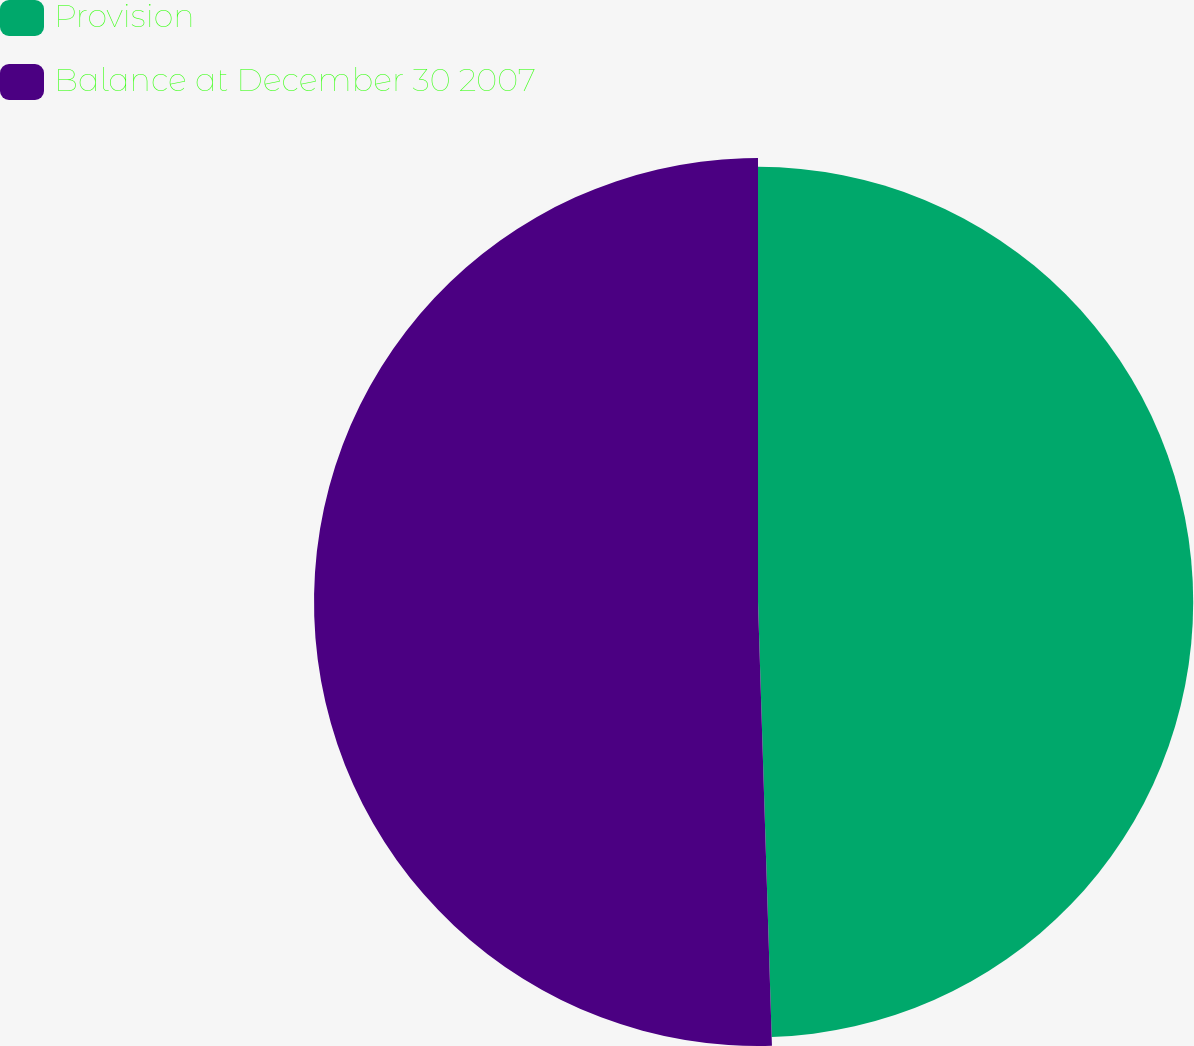Convert chart. <chart><loc_0><loc_0><loc_500><loc_500><pie_chart><fcel>Provision<fcel>Balance at December 30 2007<nl><fcel>49.5%<fcel>50.5%<nl></chart> 